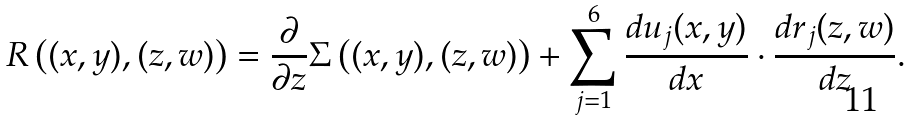Convert formula to latex. <formula><loc_0><loc_0><loc_500><loc_500>R \left ( ( x , y ) , ( z , w ) \right ) = \frac { \partial } { \partial z } \Sigma \left ( ( x , y ) , ( z , w ) \right ) + \sum _ { j = 1 } ^ { 6 } \frac { d u _ { j } ( x , y ) } { d x } \cdot \frac { d r _ { j } ( z , w ) } { d z } .</formula> 